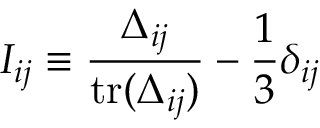Convert formula to latex. <formula><loc_0><loc_0><loc_500><loc_500>I _ { i j } \equiv \frac { \Delta _ { i j } } { t r ( \Delta _ { i j } ) } - \frac { 1 } { 3 } \delta _ { i j }</formula> 